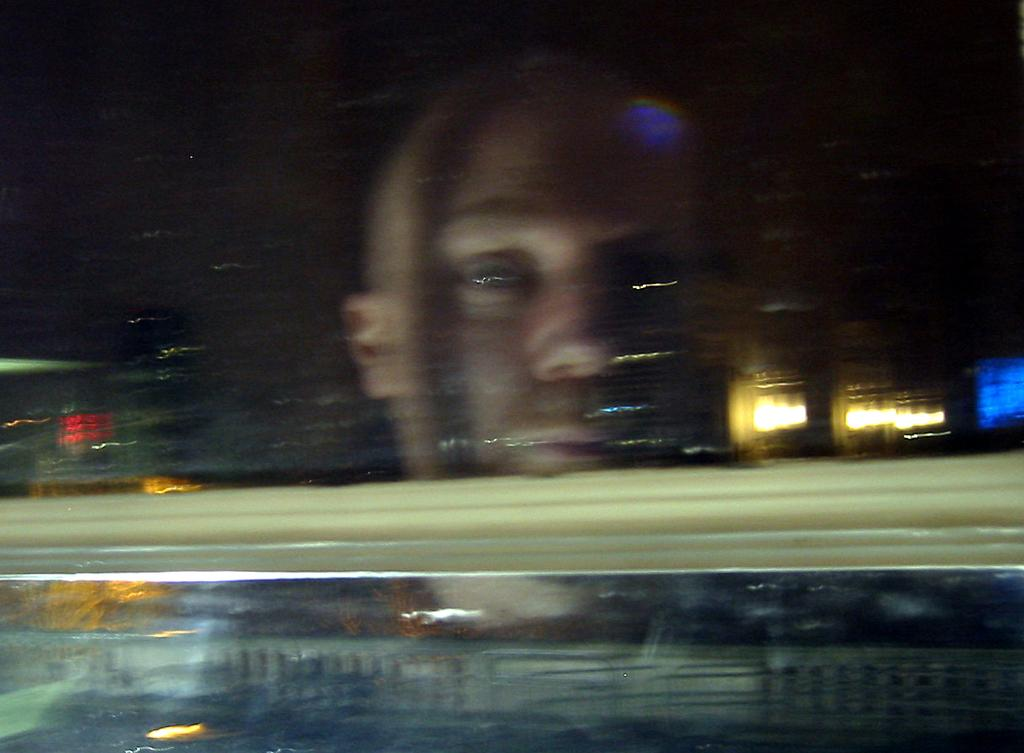Who is present in the image? There is a guy in the image. What is the guy's position in relation to the glass? The guy is behind the glass. Can you describe the background of the image? The background area of the image is blurred. What type of nail can be seen in the guy's hand in the image? There is no nail visible in the guy's hand in the image. Is there a woman present in the image? No, there is no woman present in the image; only a guy is mentioned in the facts. 